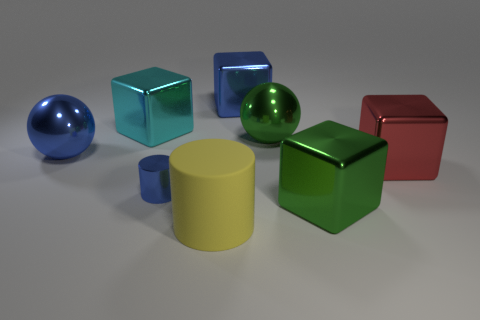Are there more red objects right of the small shiny object than tiny blue things on the left side of the cyan object?
Provide a short and direct response. Yes. Are there any green cubes in front of the blue cube?
Your answer should be very brief. Yes. Are there any green spheres that have the same size as the cyan block?
Offer a very short reply. Yes. What is the color of the other tiny object that is the same material as the cyan object?
Ensure brevity in your answer.  Blue. What material is the large blue block?
Your answer should be compact. Metal. What is the shape of the yellow matte thing?
Make the answer very short. Cylinder. How many matte cylinders are the same color as the small metal cylinder?
Offer a terse response. 0. What is the material of the cylinder in front of the green cube that is in front of the big blue shiny thing that is on the left side of the cyan block?
Your answer should be compact. Rubber. What number of green things are shiny cubes or big shiny objects?
Offer a very short reply. 2. How big is the blue object that is behind the big cube that is left of the large blue thing that is behind the cyan shiny cube?
Your answer should be very brief. Large. 